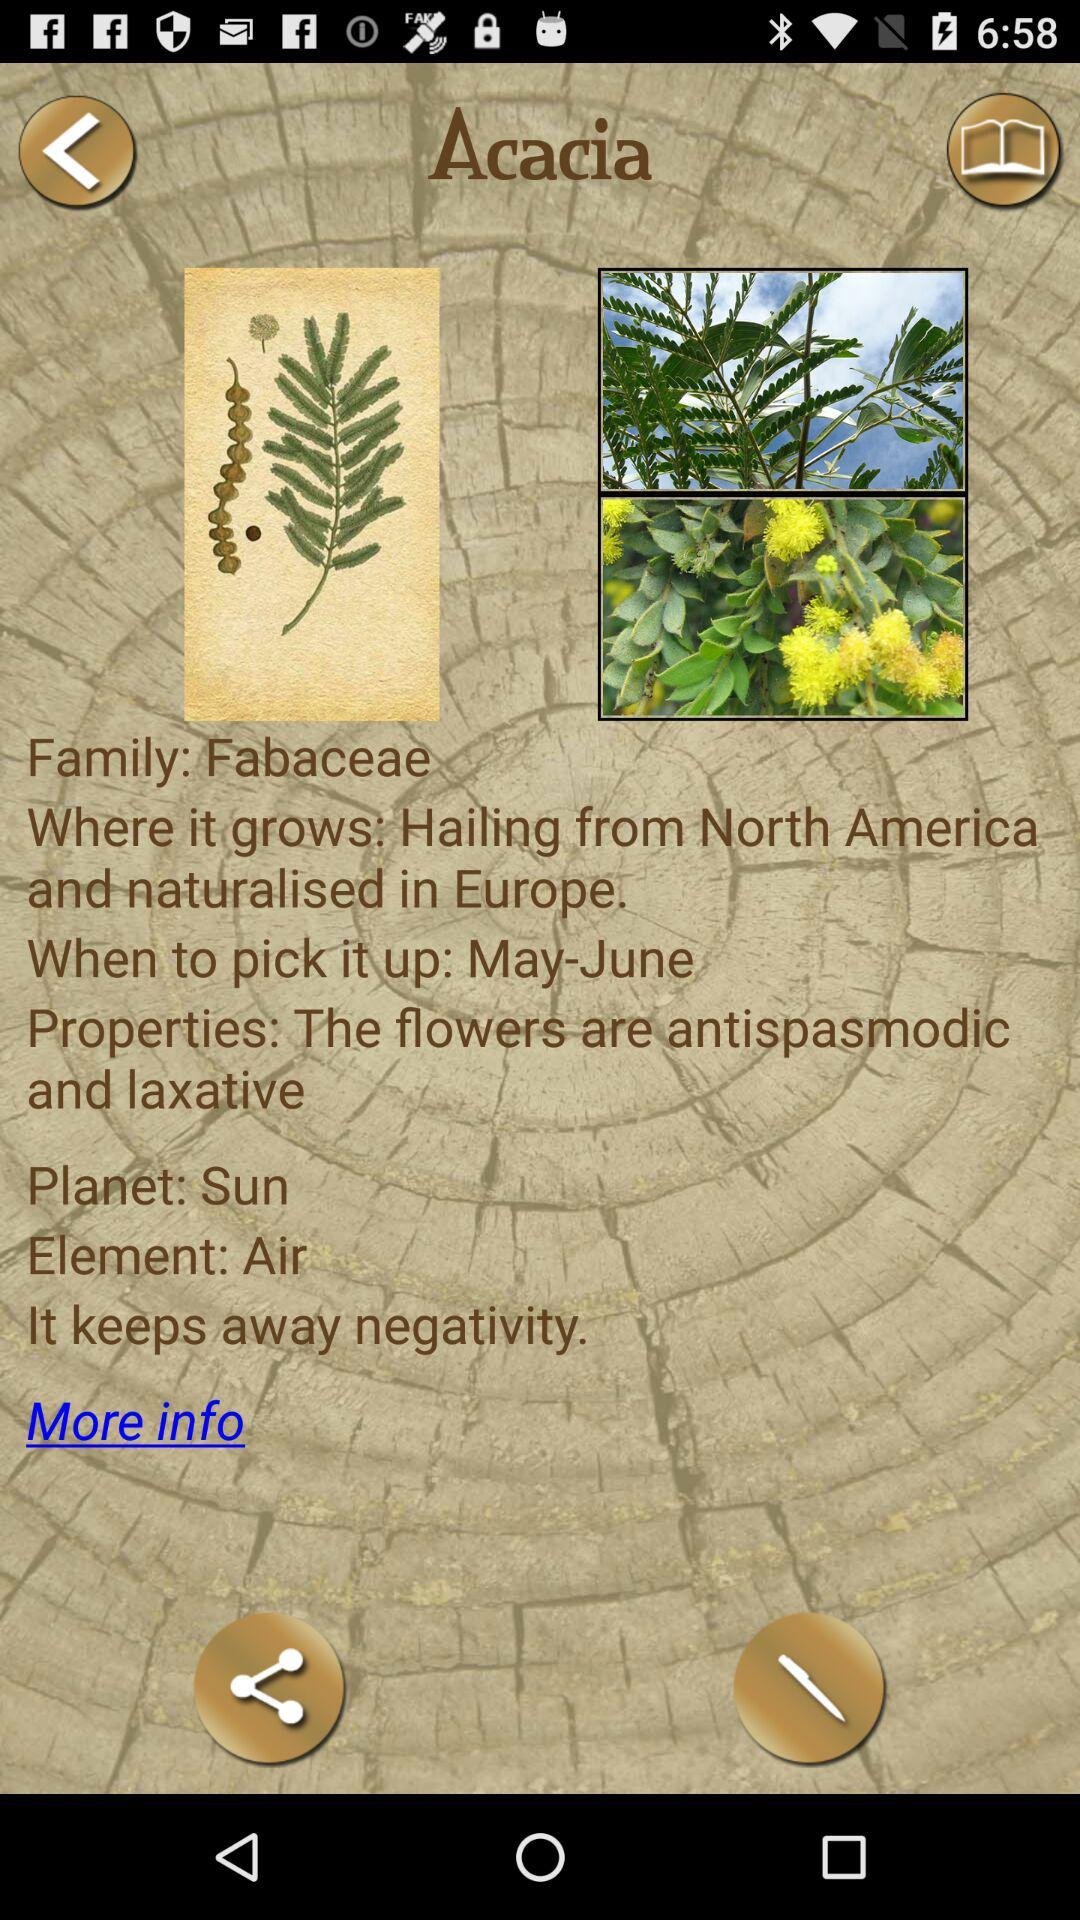When can you pick up Acacia? You can pick up Acacia in May-June. 